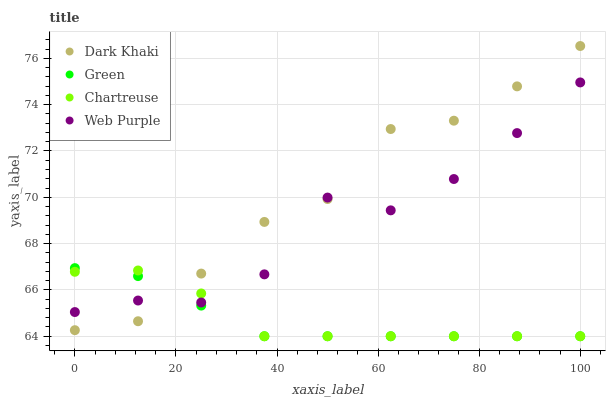Does Green have the minimum area under the curve?
Answer yes or no. Yes. Does Dark Khaki have the maximum area under the curve?
Answer yes or no. Yes. Does Chartreuse have the minimum area under the curve?
Answer yes or no. No. Does Chartreuse have the maximum area under the curve?
Answer yes or no. No. Is Green the smoothest?
Answer yes or no. Yes. Is Web Purple the roughest?
Answer yes or no. Yes. Is Chartreuse the smoothest?
Answer yes or no. No. Is Chartreuse the roughest?
Answer yes or no. No. Does Chartreuse have the lowest value?
Answer yes or no. Yes. Does Web Purple have the lowest value?
Answer yes or no. No. Does Dark Khaki have the highest value?
Answer yes or no. Yes. Does Green have the highest value?
Answer yes or no. No. Does Green intersect Web Purple?
Answer yes or no. Yes. Is Green less than Web Purple?
Answer yes or no. No. Is Green greater than Web Purple?
Answer yes or no. No. 